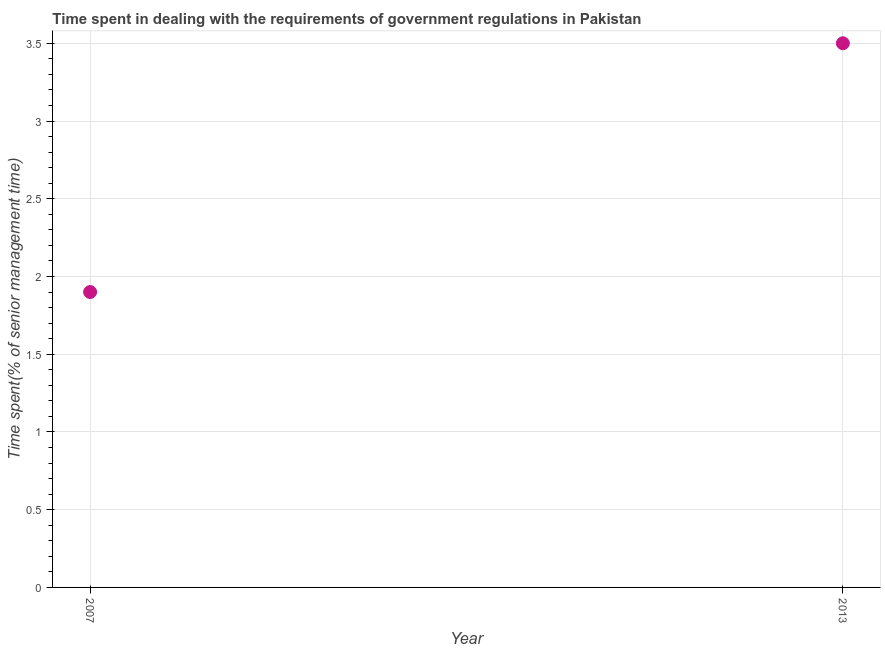What is the time spent in dealing with government regulations in 2007?
Give a very brief answer. 1.9. Across all years, what is the minimum time spent in dealing with government regulations?
Keep it short and to the point. 1.9. What is the difference between the time spent in dealing with government regulations in 2007 and 2013?
Give a very brief answer. -1.6. What is the average time spent in dealing with government regulations per year?
Offer a terse response. 2.7. What is the ratio of the time spent in dealing with government regulations in 2007 to that in 2013?
Offer a terse response. 0.54. In how many years, is the time spent in dealing with government regulations greater than the average time spent in dealing with government regulations taken over all years?
Provide a succinct answer. 1. Does the time spent in dealing with government regulations monotonically increase over the years?
Ensure brevity in your answer.  Yes. How many dotlines are there?
Ensure brevity in your answer.  1. How many years are there in the graph?
Provide a succinct answer. 2. What is the difference between two consecutive major ticks on the Y-axis?
Provide a succinct answer. 0.5. What is the title of the graph?
Provide a short and direct response. Time spent in dealing with the requirements of government regulations in Pakistan. What is the label or title of the X-axis?
Provide a succinct answer. Year. What is the label or title of the Y-axis?
Offer a very short reply. Time spent(% of senior management time). What is the difference between the Time spent(% of senior management time) in 2007 and 2013?
Offer a terse response. -1.6. What is the ratio of the Time spent(% of senior management time) in 2007 to that in 2013?
Your answer should be compact. 0.54. 